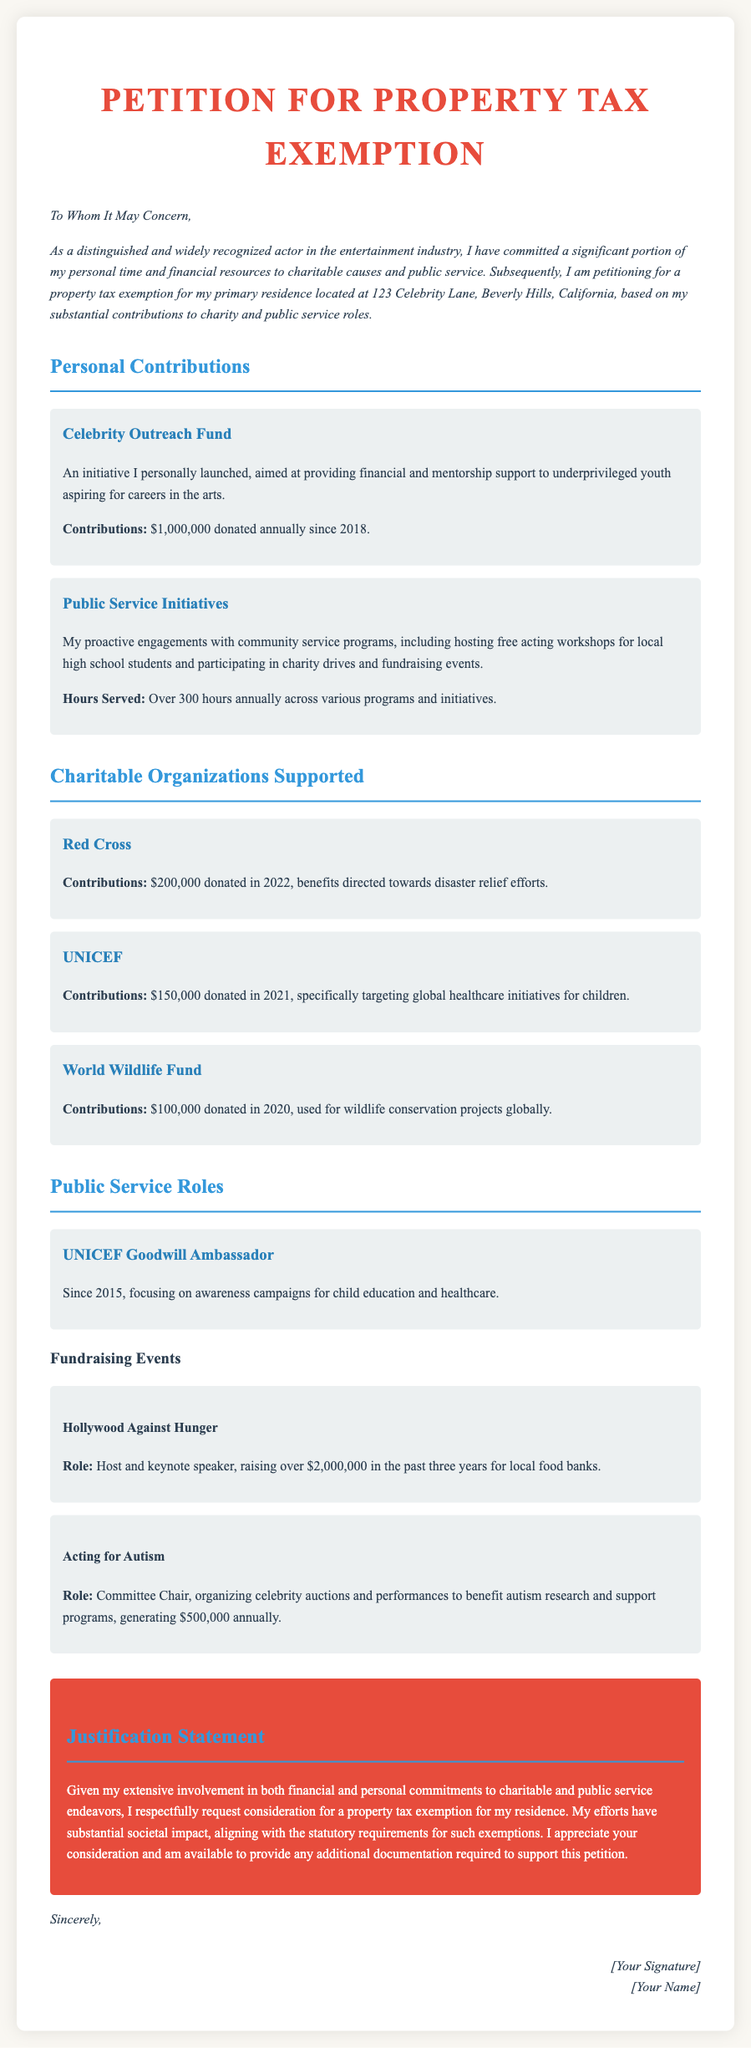What is the petitioner's residence address? The petitioner's residence address is explicitly mentioned in the introduction section of the document.
Answer: 123 Celebrity Lane, Beverly Hills, California How much has been donated to the Celebrity Outreach Fund? This information is found in the Personal Contributions section, detailing specific contributions.
Answer: $1,000,000 What organization received a donation of $200,000 in 2022? This is specified in the Charitable Organizations Supported section, outlining supported organizations and their contributions.
Answer: Red Cross What role does the petitioner hold with UNICEF? The document states the petitioner's involvement with UNICEF in the section detailing public service roles.
Answer: Goodwill Ambassador How many hours are served annually in community service? This figure is mentioned under Public Service Initiatives in the Personal Contributions section, indicating time spent on community engagement.
Answer: Over 300 hours What total amount has been raised through Hollywood Against Hunger in the past three years? This is mentioned in the Fundraising Events section, focusing on events and the total funds raised.
Answer: $2,000,000 What is the purpose of the petition? The petition's purpose is outlined in the introduction, summarizing the reason for submitting the petition.
Answer: Property tax exemption What year did the petitioner become a UNICEF Goodwill Ambassador? This information is specified in the section on public service roles, indicating the starting year.
Answer: 2015 What was the contribution amount to UNICEF in 2021? This specific financial information is provided within the Charitable Organizations Supported section of the document.
Answer: $150,000 